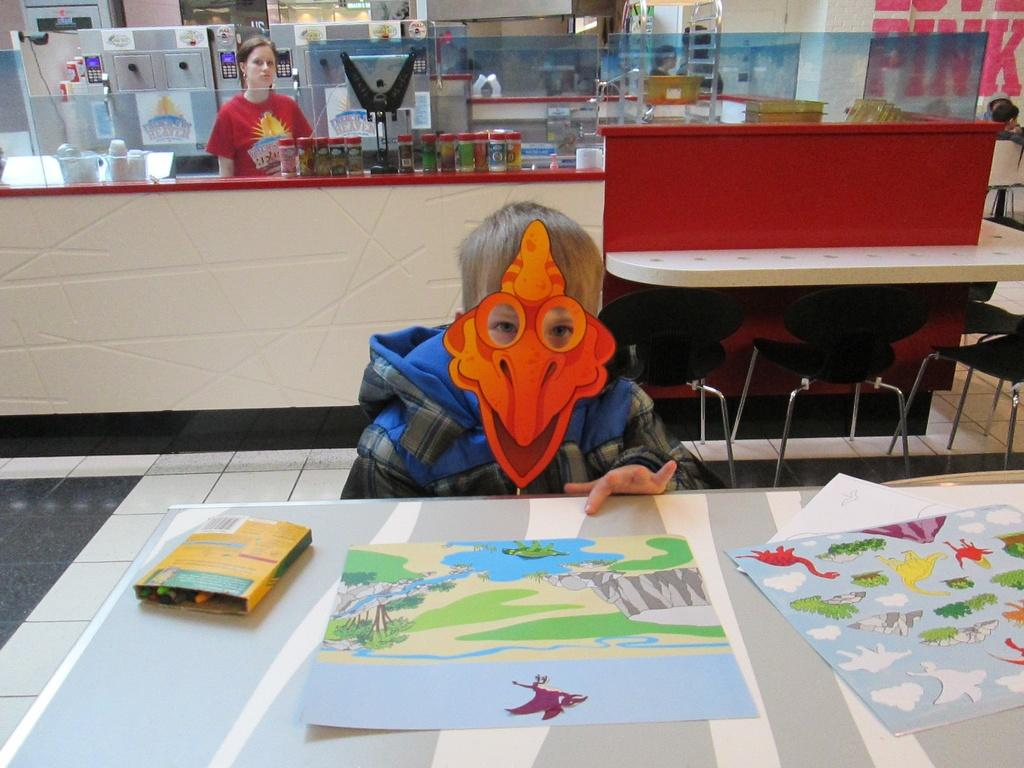What is the main subject of the image? The main subject of the image is a kid. What is the kid doing in the image? The kid is sitting on a chair in the image. What is covering the kid's face? The kid is wearing a mask on his face. What can be seen on the table in the image? There are cartoons drawn on a paper kept on the table. What type of car is the kid driving in the image? There is no car or driving activity present in the image; the kid is sitting on a chair with a mask on his face. 